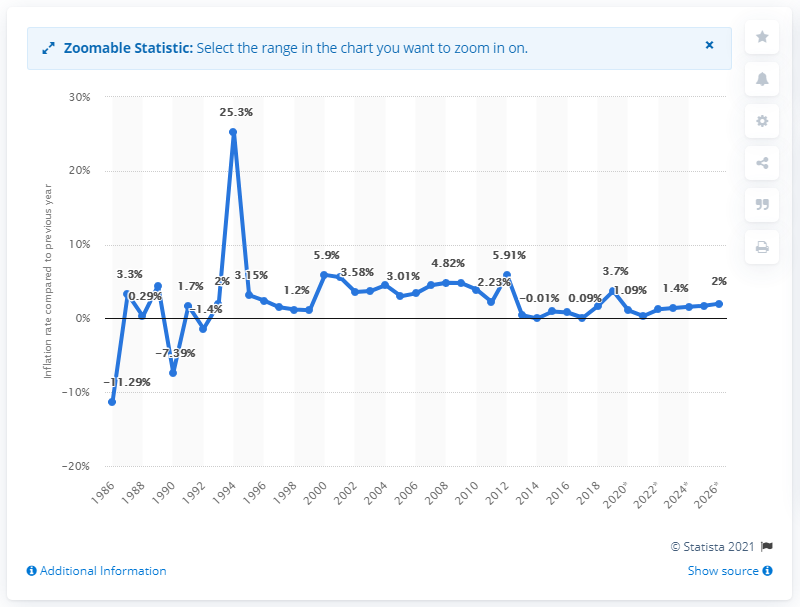What causes the fluctuations in inflation shown in this chart over the years? Inflation fluctuations can be caused by a variety of factors, including changes in national monetary policies, variations in demand for goods and services, import costs, and other economic pressures that affect the overall price levels in a country. 